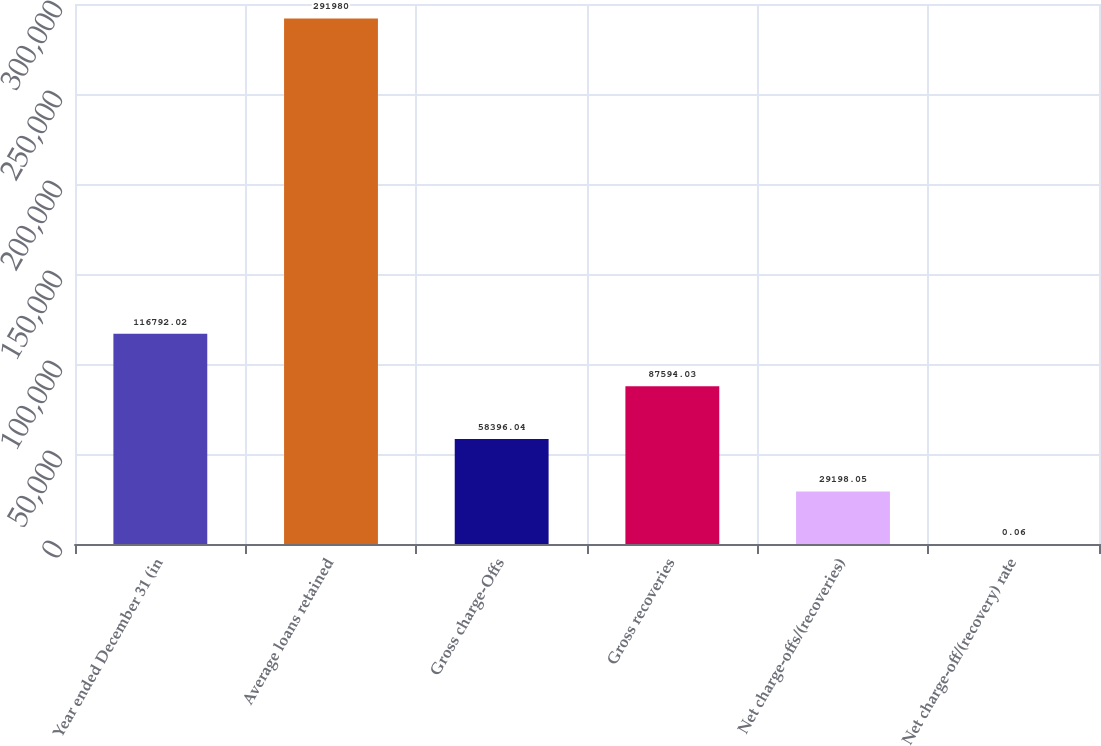Convert chart. <chart><loc_0><loc_0><loc_500><loc_500><bar_chart><fcel>Year ended December 31 (in<fcel>Average loans retained<fcel>Gross charge-Offs<fcel>Gross recoveries<fcel>Net charge-offs/(recoveries)<fcel>Net charge-off/(recovery) rate<nl><fcel>116792<fcel>291980<fcel>58396<fcel>87594<fcel>29198<fcel>0.06<nl></chart> 